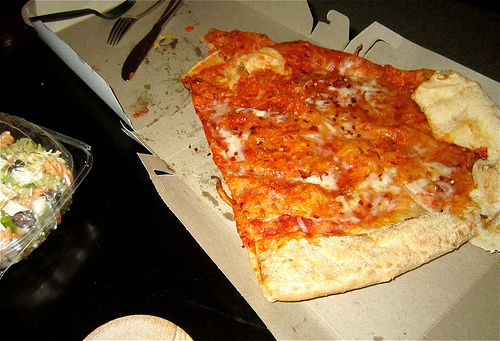Can you describe the state of the meal? It appears to be a partially eaten meal, with a few bites taken from the slice of pizza and some salad remaining in the container. The utensils and a crumpled napkin suggest someone was recently eating here. 